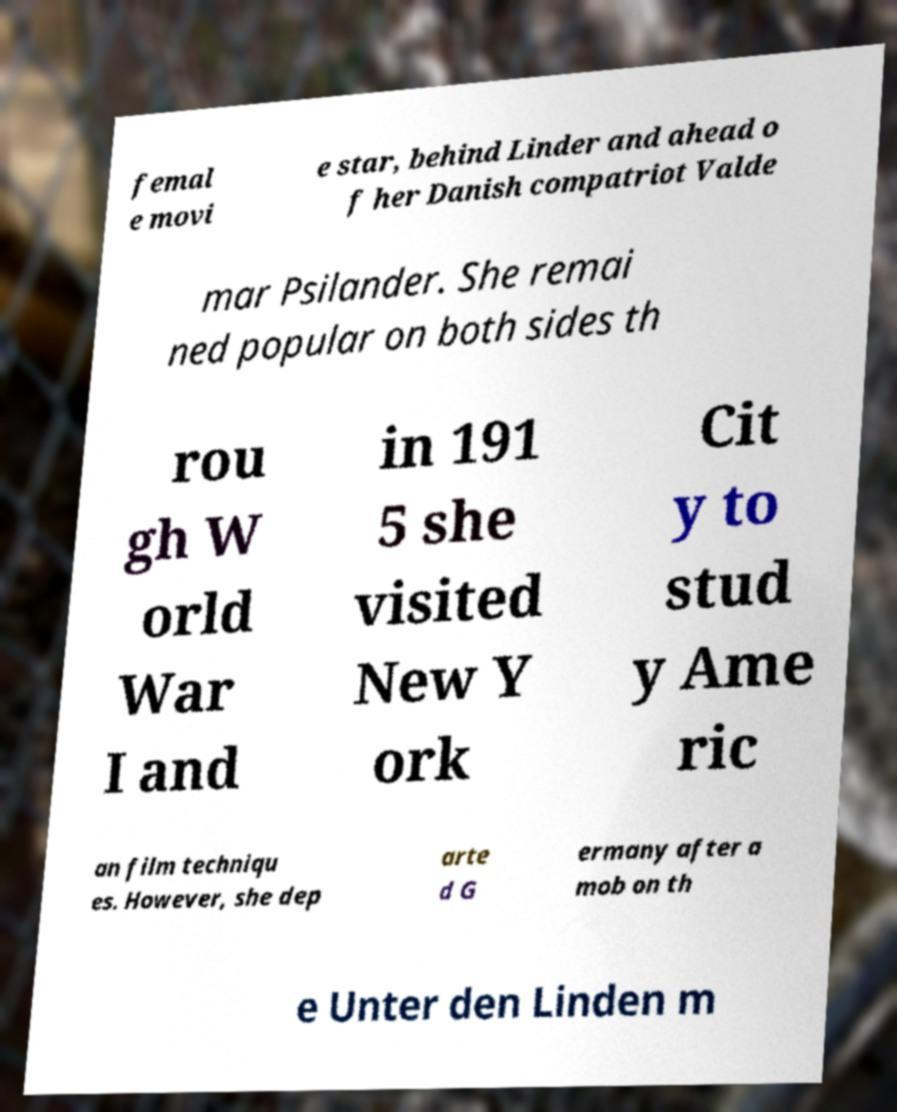Can you read and provide the text displayed in the image?This photo seems to have some interesting text. Can you extract and type it out for me? femal e movi e star, behind Linder and ahead o f her Danish compatriot Valde mar Psilander. She remai ned popular on both sides th rou gh W orld War I and in 191 5 she visited New Y ork Cit y to stud y Ame ric an film techniqu es. However, she dep arte d G ermany after a mob on th e Unter den Linden m 